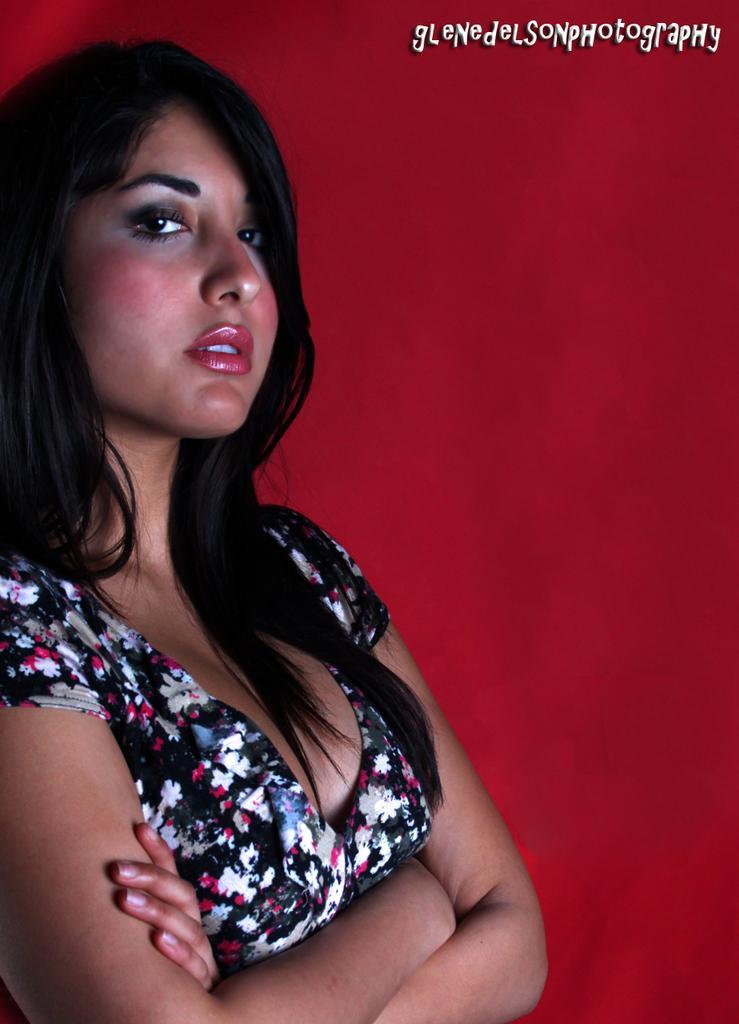Could you give a brief overview of what you see in this image? In this picture, we can see a woman is standing and there is a red background and on the image there is a watermark. 